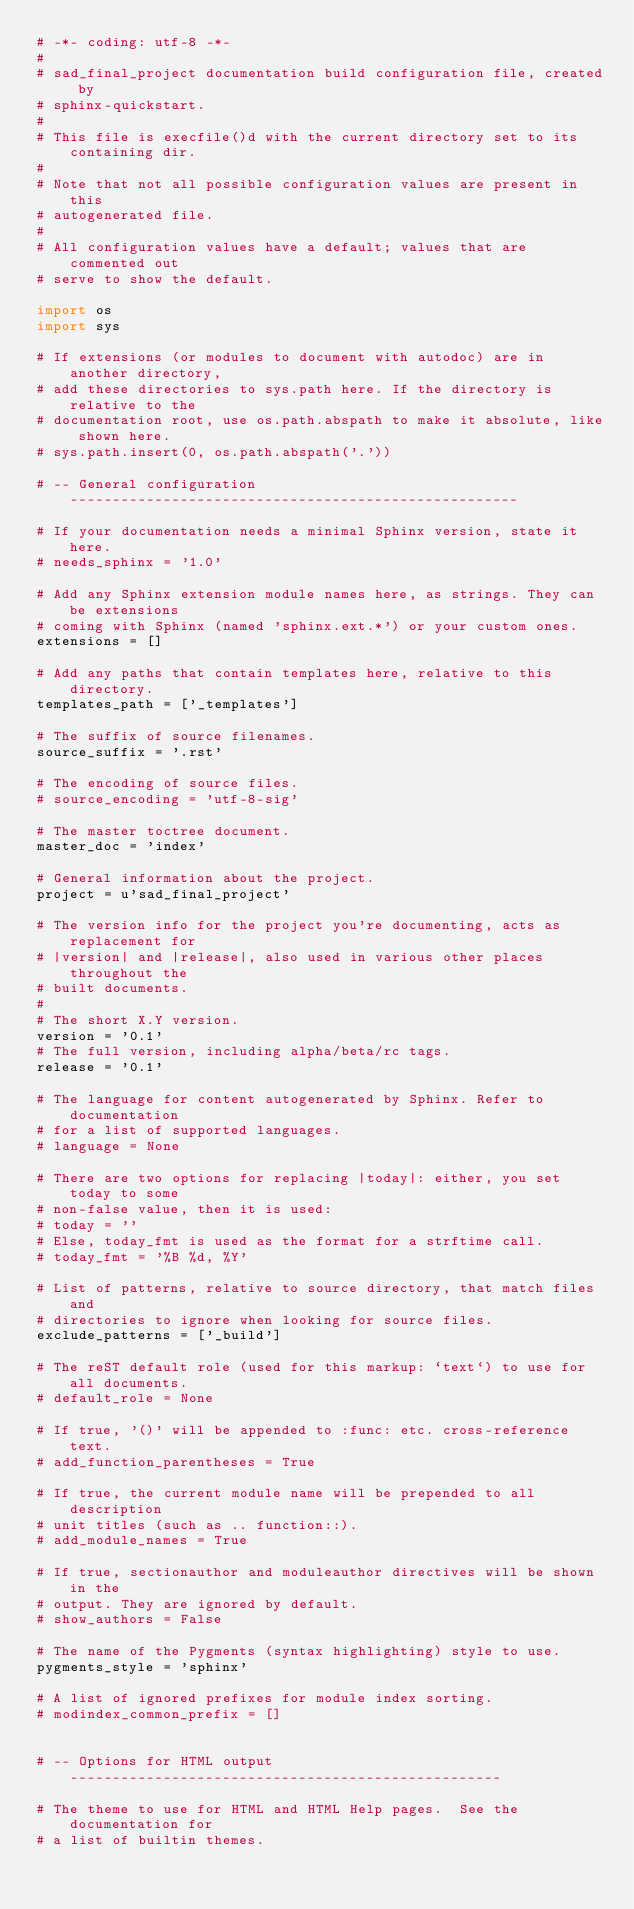Convert code to text. <code><loc_0><loc_0><loc_500><loc_500><_Python_># -*- coding: utf-8 -*-
#
# sad_final_project documentation build configuration file, created by
# sphinx-quickstart.
#
# This file is execfile()d with the current directory set to its containing dir.
#
# Note that not all possible configuration values are present in this
# autogenerated file.
#
# All configuration values have a default; values that are commented out
# serve to show the default.

import os
import sys

# If extensions (or modules to document with autodoc) are in another directory,
# add these directories to sys.path here. If the directory is relative to the
# documentation root, use os.path.abspath to make it absolute, like shown here.
# sys.path.insert(0, os.path.abspath('.'))

# -- General configuration -----------------------------------------------------

# If your documentation needs a minimal Sphinx version, state it here.
# needs_sphinx = '1.0'

# Add any Sphinx extension module names here, as strings. They can be extensions
# coming with Sphinx (named 'sphinx.ext.*') or your custom ones.
extensions = []

# Add any paths that contain templates here, relative to this directory.
templates_path = ['_templates']

# The suffix of source filenames.
source_suffix = '.rst'

# The encoding of source files.
# source_encoding = 'utf-8-sig'

# The master toctree document.
master_doc = 'index'

# General information about the project.
project = u'sad_final_project'

# The version info for the project you're documenting, acts as replacement for
# |version| and |release|, also used in various other places throughout the
# built documents.
#
# The short X.Y version.
version = '0.1'
# The full version, including alpha/beta/rc tags.
release = '0.1'

# The language for content autogenerated by Sphinx. Refer to documentation
# for a list of supported languages.
# language = None

# There are two options for replacing |today|: either, you set today to some
# non-false value, then it is used:
# today = ''
# Else, today_fmt is used as the format for a strftime call.
# today_fmt = '%B %d, %Y'

# List of patterns, relative to source directory, that match files and
# directories to ignore when looking for source files.
exclude_patterns = ['_build']

# The reST default role (used for this markup: `text`) to use for all documents.
# default_role = None

# If true, '()' will be appended to :func: etc. cross-reference text.
# add_function_parentheses = True

# If true, the current module name will be prepended to all description
# unit titles (such as .. function::).
# add_module_names = True

# If true, sectionauthor and moduleauthor directives will be shown in the
# output. They are ignored by default.
# show_authors = False

# The name of the Pygments (syntax highlighting) style to use.
pygments_style = 'sphinx'

# A list of ignored prefixes for module index sorting.
# modindex_common_prefix = []


# -- Options for HTML output ---------------------------------------------------

# The theme to use for HTML and HTML Help pages.  See the documentation for
# a list of builtin themes.</code> 